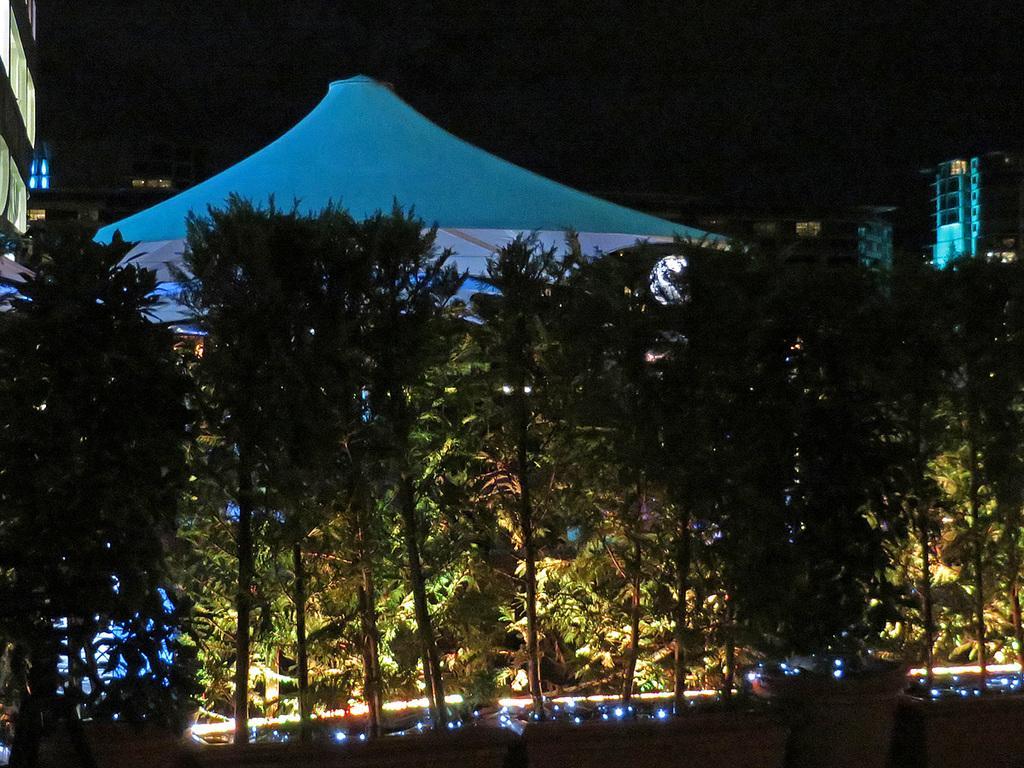In one or two sentences, can you explain what this image depicts? In the center of the image there are trees and there is a tent. At the bottom there are lights. In the background there are buildings and sky. 